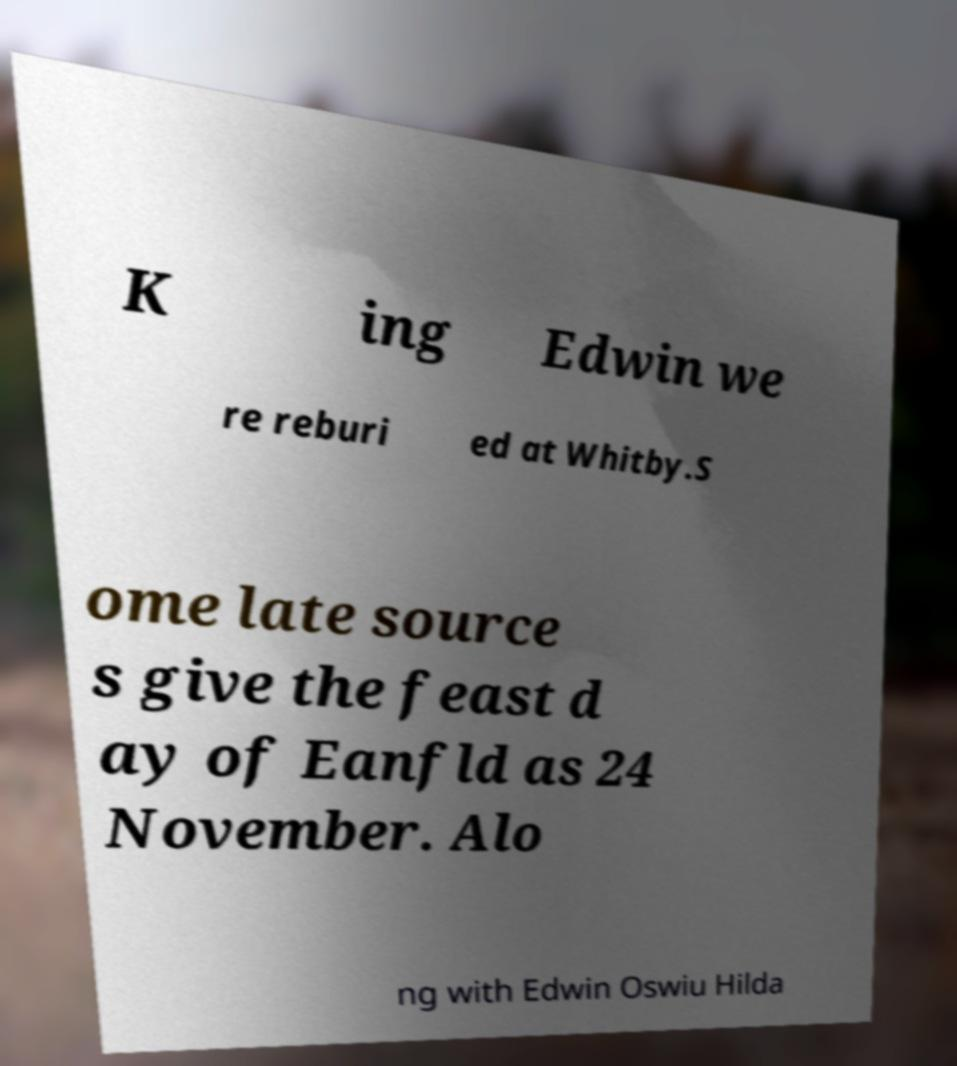Could you extract and type out the text from this image? K ing Edwin we re reburi ed at Whitby.S ome late source s give the feast d ay of Eanfld as 24 November. Alo ng with Edwin Oswiu Hilda 